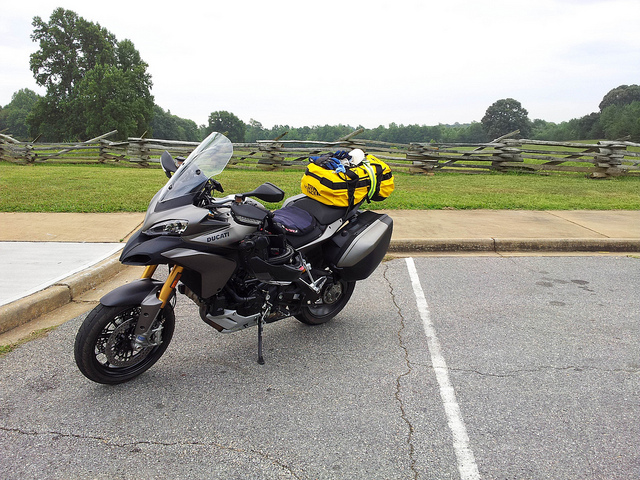<image>Is this photo taken in a big city? No, this photo is not taken in a big city. Is this photo taken in a big city? I don't know if this photo is taken in a big city. It seems like it is not. 